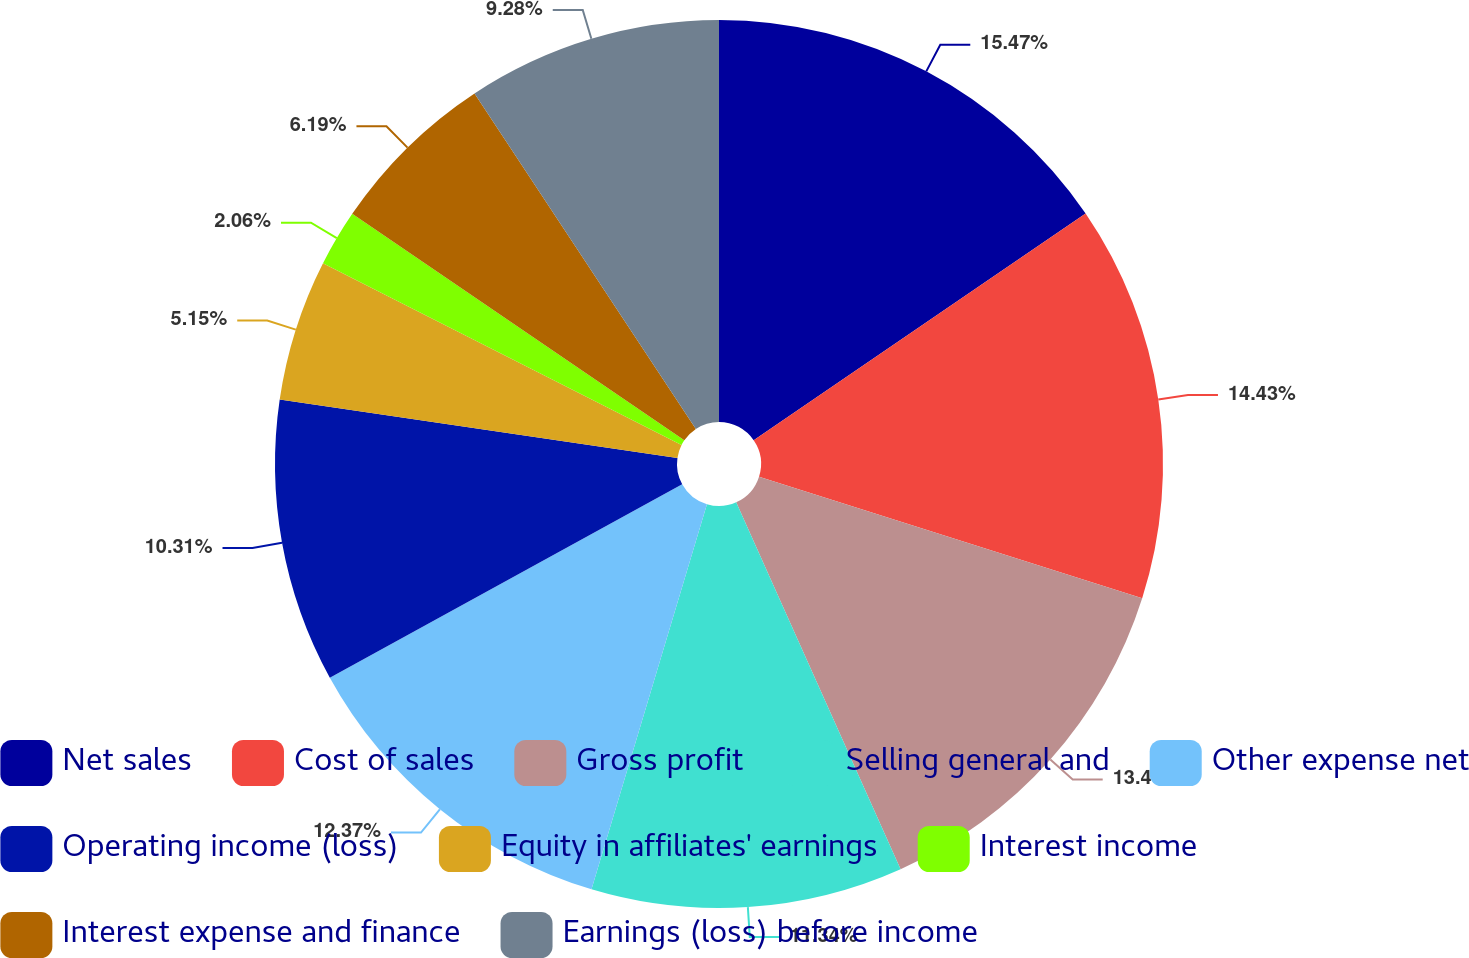Convert chart to OTSL. <chart><loc_0><loc_0><loc_500><loc_500><pie_chart><fcel>Net sales<fcel>Cost of sales<fcel>Gross profit<fcel>Selling general and<fcel>Other expense net<fcel>Operating income (loss)<fcel>Equity in affiliates' earnings<fcel>Interest income<fcel>Interest expense and finance<fcel>Earnings (loss) before income<nl><fcel>15.46%<fcel>14.43%<fcel>13.4%<fcel>11.34%<fcel>12.37%<fcel>10.31%<fcel>5.15%<fcel>2.06%<fcel>6.19%<fcel>9.28%<nl></chart> 